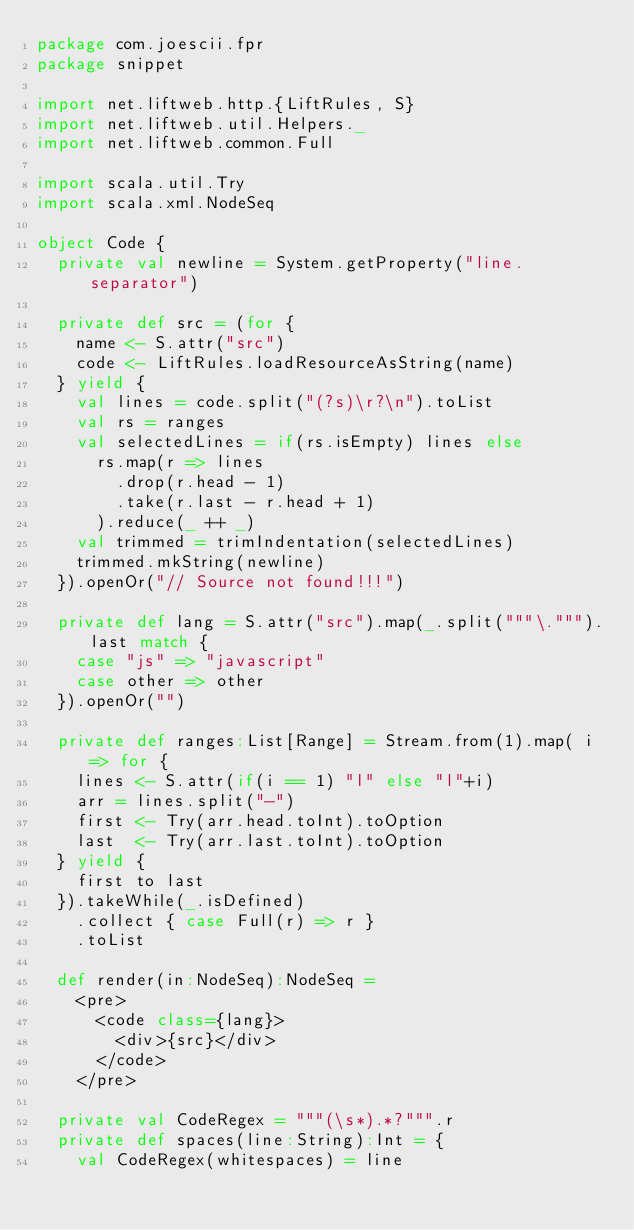<code> <loc_0><loc_0><loc_500><loc_500><_Scala_>package com.joescii.fpr
package snippet

import net.liftweb.http.{LiftRules, S}
import net.liftweb.util.Helpers._
import net.liftweb.common.Full

import scala.util.Try
import scala.xml.NodeSeq

object Code {
  private val newline = System.getProperty("line.separator")

  private def src = (for {
    name <- S.attr("src")
    code <- LiftRules.loadResourceAsString(name)
  } yield {
    val lines = code.split("(?s)\r?\n").toList
    val rs = ranges
    val selectedLines = if(rs.isEmpty) lines else
      rs.map(r => lines
        .drop(r.head - 1)
        .take(r.last - r.head + 1)
      ).reduce(_ ++ _)
    val trimmed = trimIndentation(selectedLines)
    trimmed.mkString(newline)
  }).openOr("// Source not found!!!")

  private def lang = S.attr("src").map(_.split("""\.""").last match {
    case "js" => "javascript"
    case other => other
  }).openOr("")

  private def ranges:List[Range] = Stream.from(1).map( i => for {
    lines <- S.attr(if(i == 1) "l" else "l"+i)
    arr = lines.split("-")
    first <- Try(arr.head.toInt).toOption
    last  <- Try(arr.last.toInt).toOption
  } yield {
    first to last
  }).takeWhile(_.isDefined)
    .collect { case Full(r) => r }
    .toList

  def render(in:NodeSeq):NodeSeq =
    <pre>
      <code class={lang}>
        <div>{src}</div>
      </code>
    </pre>

  private val CodeRegex = """(\s*).*?""".r
  private def spaces(line:String):Int = {
    val CodeRegex(whitespaces) = line</code> 